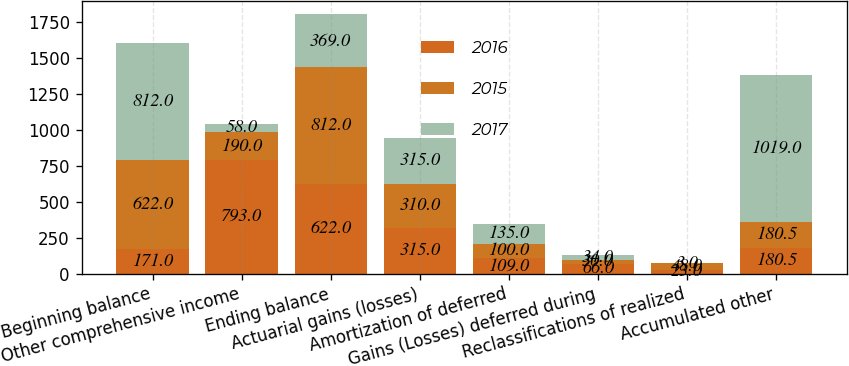<chart> <loc_0><loc_0><loc_500><loc_500><stacked_bar_chart><ecel><fcel>Beginning balance<fcel>Other comprehensive income<fcel>Ending balance<fcel>Actuarial gains (losses)<fcel>Amortization of deferred<fcel>Gains (Losses) deferred during<fcel>Reclassifications of realized<fcel>Accumulated other<nl><fcel>2016<fcel>171<fcel>793<fcel>622<fcel>315<fcel>109<fcel>66<fcel>23<fcel>180.5<nl><fcel>2015<fcel>622<fcel>190<fcel>812<fcel>310<fcel>100<fcel>30<fcel>48<fcel>180.5<nl><fcel>2017<fcel>812<fcel>58<fcel>369<fcel>315<fcel>135<fcel>34<fcel>3<fcel>1019<nl></chart> 